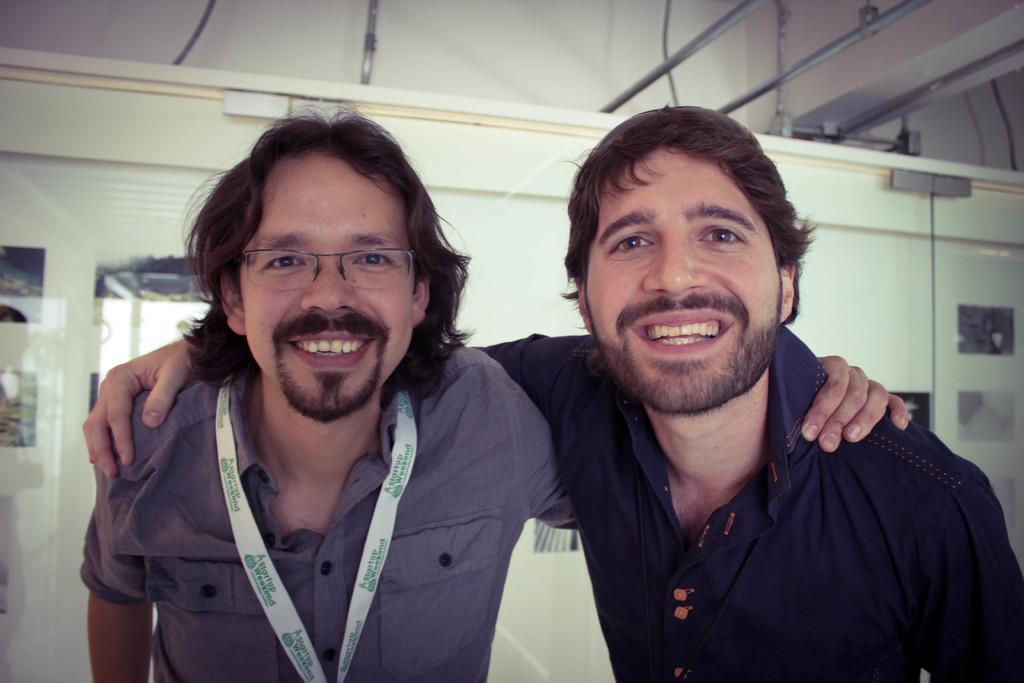How would you summarize this image in a sentence or two? In the image two persons are standing and smiling. Behind them there is a wall. 